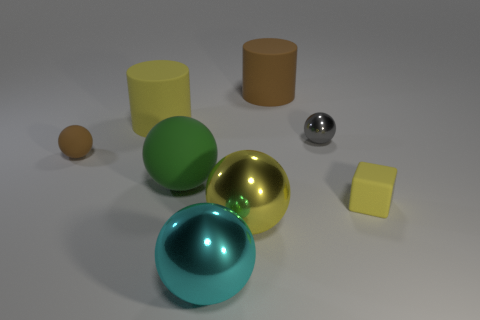Subtract 1 balls. How many balls are left? 4 Subtract all brown balls. How many balls are left? 4 Subtract all purple balls. Subtract all green cubes. How many balls are left? 5 Add 2 small purple rubber balls. How many objects exist? 10 Subtract all balls. How many objects are left? 3 Add 7 yellow cylinders. How many yellow cylinders are left? 8 Add 3 large green blocks. How many large green blocks exist? 3 Subtract 0 blue balls. How many objects are left? 8 Subtract all large yellow cylinders. Subtract all small cubes. How many objects are left? 6 